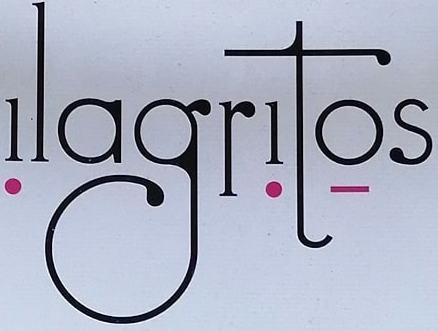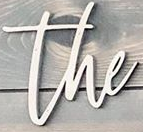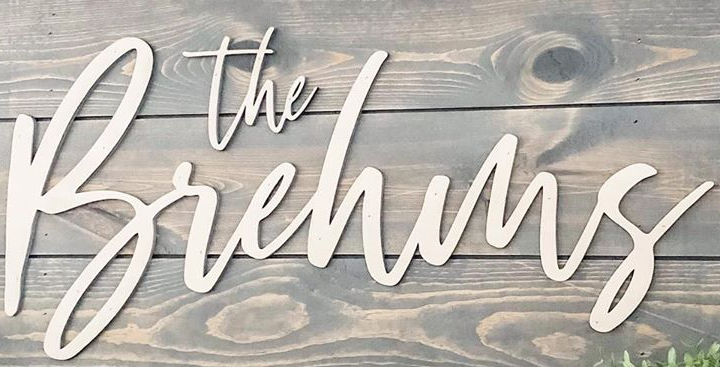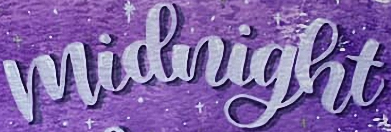What words are shown in these images in order, separated by a semicolon? ǃlagrǃtọs; the; Brehms; midnight 